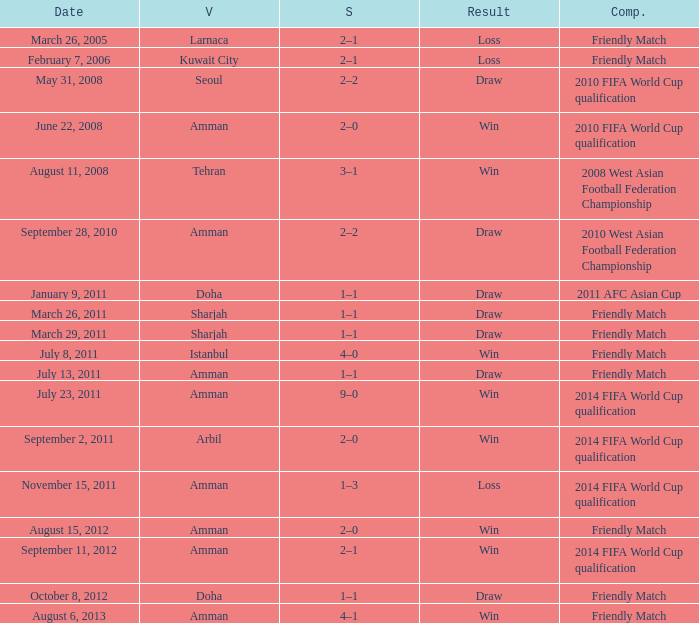During the loss on march 26, 2005, what was the venue where the match was played? Larnaca. 